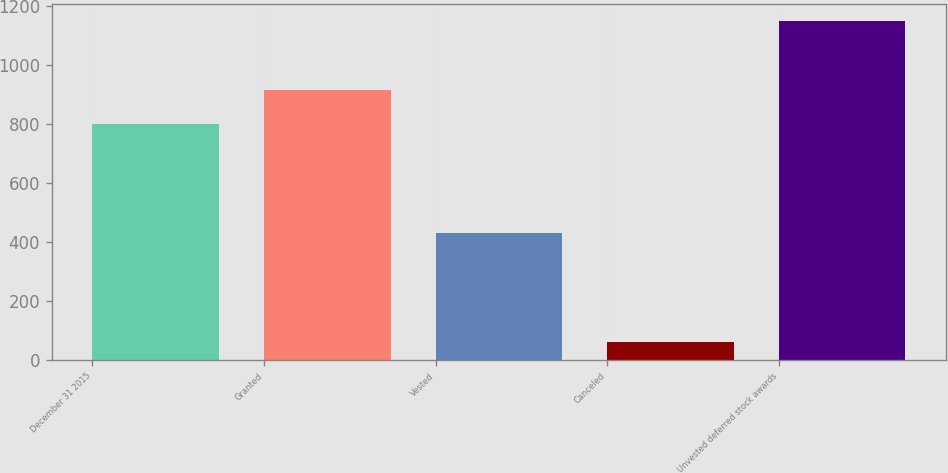Convert chart to OTSL. <chart><loc_0><loc_0><loc_500><loc_500><bar_chart><fcel>December 31 2015<fcel>Granted<fcel>Vested<fcel>Canceled<fcel>Unvested deferred stock awards<nl><fcel>800<fcel>914.6<fcel>430<fcel>61<fcel>1151<nl></chart> 